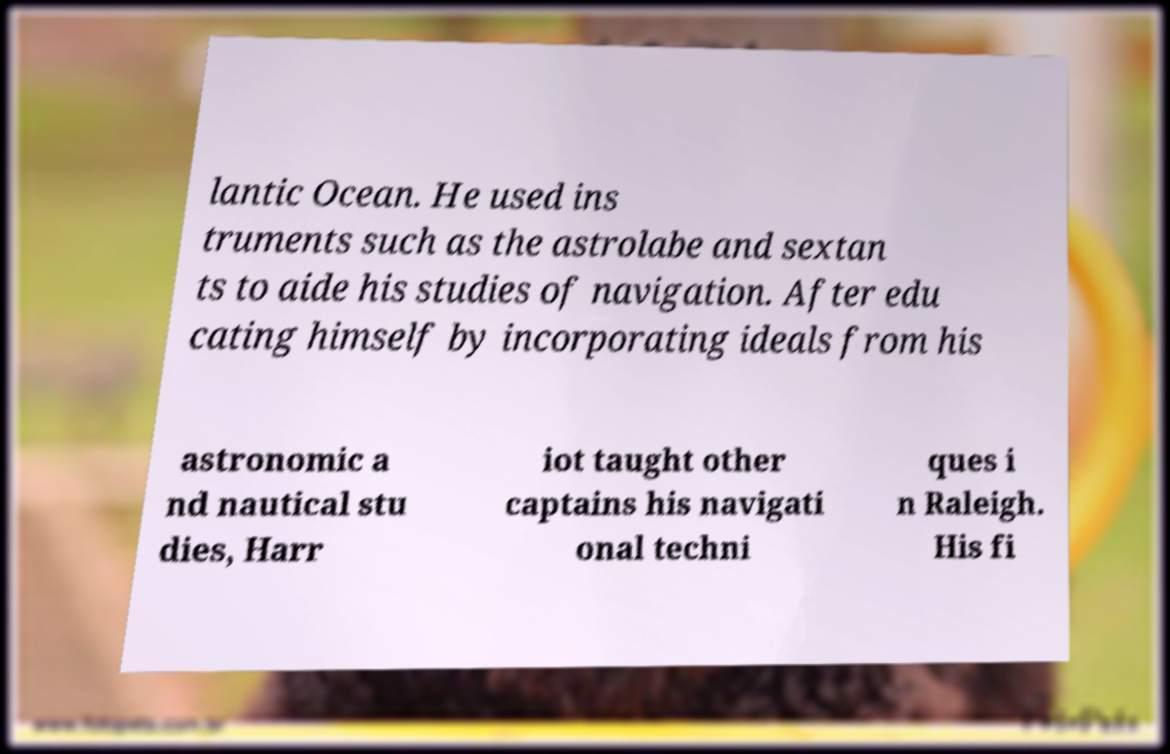There's text embedded in this image that I need extracted. Can you transcribe it verbatim? lantic Ocean. He used ins truments such as the astrolabe and sextan ts to aide his studies of navigation. After edu cating himself by incorporating ideals from his astronomic a nd nautical stu dies, Harr iot taught other captains his navigati onal techni ques i n Raleigh. His fi 